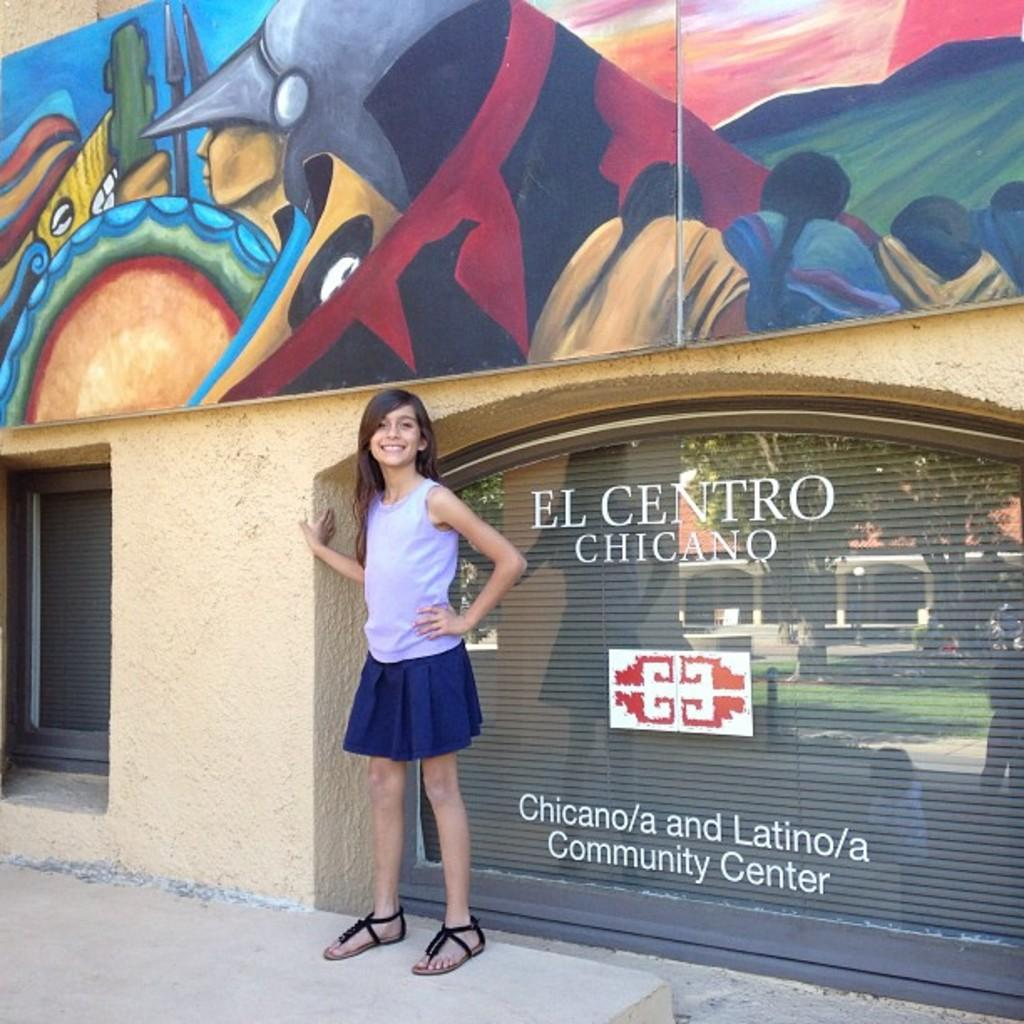<image>
Render a clear and concise summary of the photo. A girl stands in front of a community center with a colourful mural. 